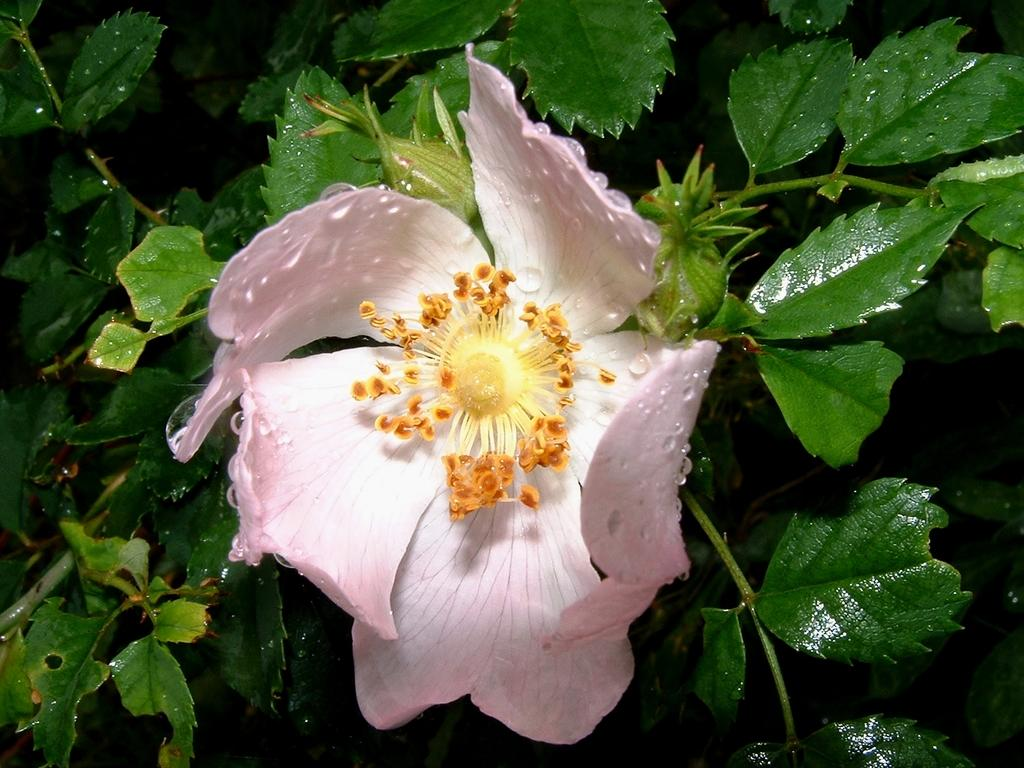What type of plant is in the image? There is a plant in the image. What color are the flowers on the plant? The plant has pink flowers. Can you describe any additional features of the plant? There are water drops on the plant. What disease is the plant suffering from in the image? There is no indication in the image that the plant is suffering from any disease. 